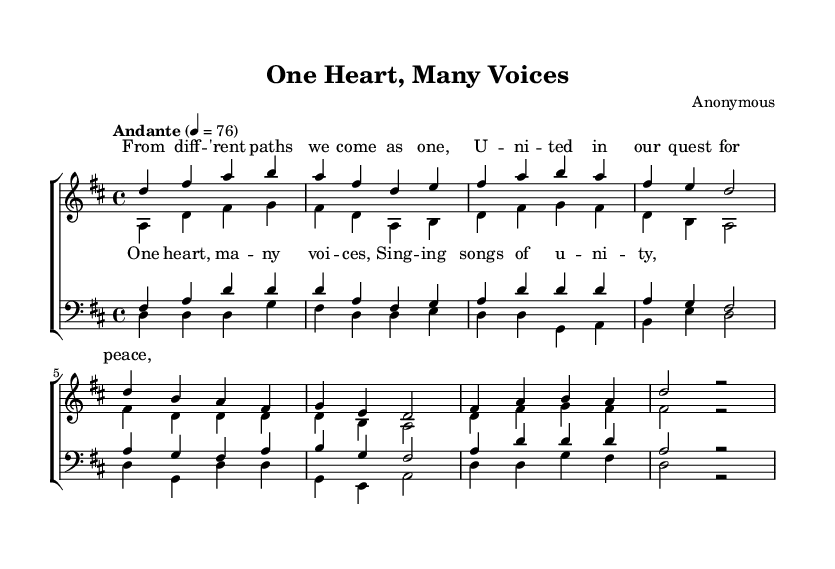What is the key signature of this music? The key signature is indicated at the beginning of the score. It shows two sharps (F# and C#), which designates the key of D major.
Answer: D major What is the time signature of this music? The time signature is specified just after the key signature in the score, represented as 4/4. This means there are four beats per measure, and the quarter note gets one beat.
Answer: 4/4 What is the tempo marking of this piece? The tempo marking is found in the score, which indicates that the piece should be played at an "Andante" speed, equating to a tempo of 76 beats per minute.
Answer: Andante, 76 How many voices are in the choral composition? By analyzing the score structure, it includes two parts for women (sopranos and altos) and two parts for men (tenors and basses), totaling four distinct voices.
Answer: Four In which section do we find the lyrics "One heart, many voices"? The lyrics are explicitly written under the chorus section of the sopranos, indicating that they sing these words during the chorus.
Answer: Soprano chorus What are the themes expressed in the lyrics? The lyrics of the verse discuss unity in diversity through a shared quest for peace, reflecting a prominent theme of interfaith and choral harmony among different groups.
Answer: Unity and peace How does the structure of this piece contribute to the concept of interfaith harmony? The piece utilizes multiple voices and harmonizes them together, portraying the idea of different faiths and backgrounds coming together to create one unified sound, reflecting interfaith unity.
Answer: Harmonious collaboration 